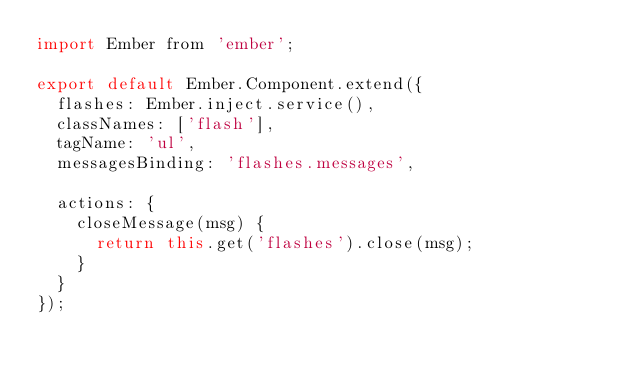<code> <loc_0><loc_0><loc_500><loc_500><_JavaScript_>import Ember from 'ember';

export default Ember.Component.extend({
  flashes: Ember.inject.service(),
  classNames: ['flash'],
  tagName: 'ul',
  messagesBinding: 'flashes.messages',

  actions: {
    closeMessage(msg) {
      return this.get('flashes').close(msg);
    }
  }
});
</code> 